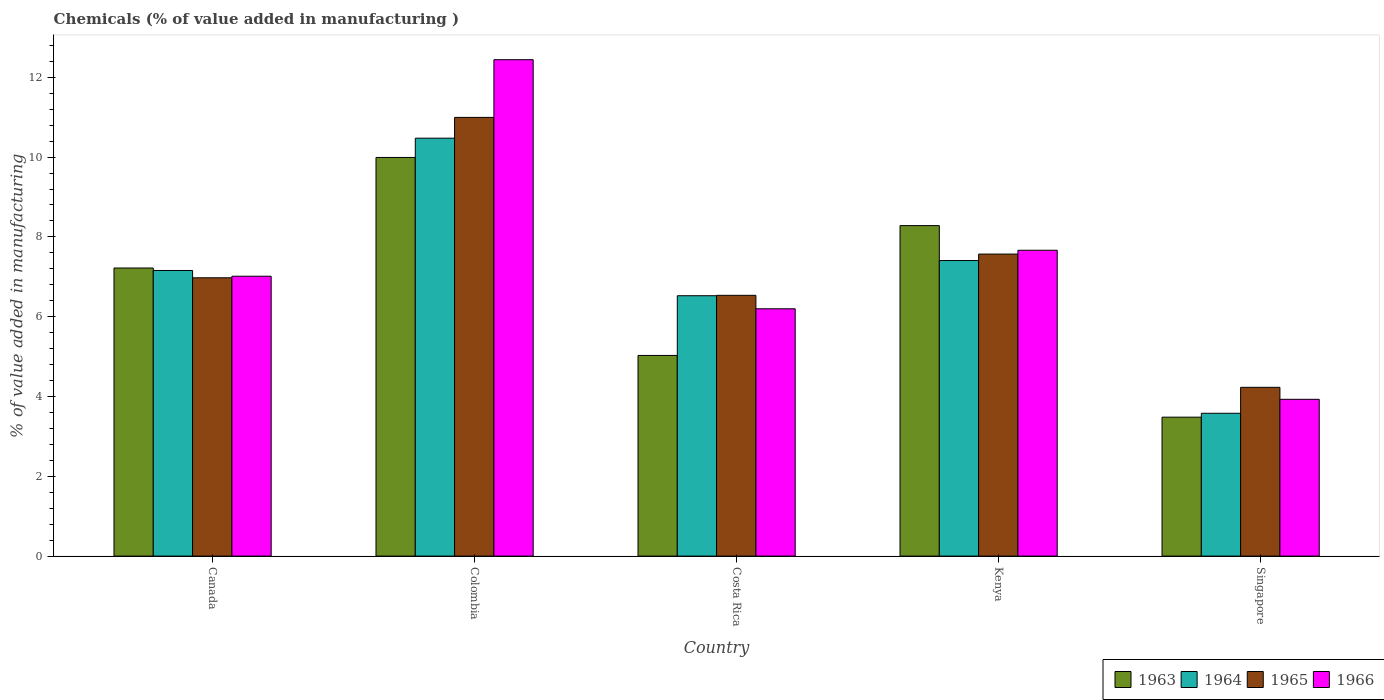How many groups of bars are there?
Your answer should be compact. 5. Are the number of bars on each tick of the X-axis equal?
Ensure brevity in your answer.  Yes. How many bars are there on the 2nd tick from the left?
Your answer should be compact. 4. What is the label of the 4th group of bars from the left?
Keep it short and to the point. Kenya. In how many cases, is the number of bars for a given country not equal to the number of legend labels?
Your answer should be very brief. 0. What is the value added in manufacturing chemicals in 1966 in Singapore?
Your answer should be compact. 3.93. Across all countries, what is the maximum value added in manufacturing chemicals in 1966?
Keep it short and to the point. 12.44. Across all countries, what is the minimum value added in manufacturing chemicals in 1966?
Provide a succinct answer. 3.93. In which country was the value added in manufacturing chemicals in 1965 minimum?
Offer a very short reply. Singapore. What is the total value added in manufacturing chemicals in 1965 in the graph?
Offer a very short reply. 36.31. What is the difference between the value added in manufacturing chemicals in 1966 in Colombia and that in Singapore?
Make the answer very short. 8.51. What is the difference between the value added in manufacturing chemicals in 1965 in Colombia and the value added in manufacturing chemicals in 1966 in Costa Rica?
Provide a short and direct response. 4.8. What is the average value added in manufacturing chemicals in 1963 per country?
Keep it short and to the point. 6.8. What is the difference between the value added in manufacturing chemicals of/in 1963 and value added in manufacturing chemicals of/in 1966 in Kenya?
Offer a terse response. 0.62. In how many countries, is the value added in manufacturing chemicals in 1963 greater than 4.4 %?
Keep it short and to the point. 4. What is the ratio of the value added in manufacturing chemicals in 1965 in Kenya to that in Singapore?
Make the answer very short. 1.79. Is the value added in manufacturing chemicals in 1963 in Colombia less than that in Kenya?
Your response must be concise. No. Is the difference between the value added in manufacturing chemicals in 1963 in Colombia and Costa Rica greater than the difference between the value added in manufacturing chemicals in 1966 in Colombia and Costa Rica?
Ensure brevity in your answer.  No. What is the difference between the highest and the second highest value added in manufacturing chemicals in 1965?
Offer a very short reply. 4.02. What is the difference between the highest and the lowest value added in manufacturing chemicals in 1963?
Your response must be concise. 6.51. In how many countries, is the value added in manufacturing chemicals in 1965 greater than the average value added in manufacturing chemicals in 1965 taken over all countries?
Provide a succinct answer. 2. Is the sum of the value added in manufacturing chemicals in 1963 in Costa Rica and Singapore greater than the maximum value added in manufacturing chemicals in 1965 across all countries?
Ensure brevity in your answer.  No. What does the 3rd bar from the left in Colombia represents?
Make the answer very short. 1965. What does the 1st bar from the right in Colombia represents?
Your answer should be very brief. 1966. Are all the bars in the graph horizontal?
Ensure brevity in your answer.  No. How many countries are there in the graph?
Provide a succinct answer. 5. What is the difference between two consecutive major ticks on the Y-axis?
Provide a short and direct response. 2. Are the values on the major ticks of Y-axis written in scientific E-notation?
Give a very brief answer. No. Does the graph contain any zero values?
Offer a very short reply. No. Does the graph contain grids?
Keep it short and to the point. No. Where does the legend appear in the graph?
Give a very brief answer. Bottom right. How many legend labels are there?
Keep it short and to the point. 4. What is the title of the graph?
Your response must be concise. Chemicals (% of value added in manufacturing ). What is the label or title of the X-axis?
Keep it short and to the point. Country. What is the label or title of the Y-axis?
Your answer should be compact. % of value added in manufacturing. What is the % of value added in manufacturing in 1963 in Canada?
Your response must be concise. 7.22. What is the % of value added in manufacturing of 1964 in Canada?
Keep it short and to the point. 7.16. What is the % of value added in manufacturing in 1965 in Canada?
Your answer should be very brief. 6.98. What is the % of value added in manufacturing in 1966 in Canada?
Offer a very short reply. 7.01. What is the % of value added in manufacturing in 1963 in Colombia?
Ensure brevity in your answer.  9.99. What is the % of value added in manufacturing in 1964 in Colombia?
Ensure brevity in your answer.  10.47. What is the % of value added in manufacturing of 1965 in Colombia?
Your answer should be compact. 10.99. What is the % of value added in manufacturing in 1966 in Colombia?
Your answer should be compact. 12.44. What is the % of value added in manufacturing in 1963 in Costa Rica?
Offer a terse response. 5.03. What is the % of value added in manufacturing of 1964 in Costa Rica?
Give a very brief answer. 6.53. What is the % of value added in manufacturing of 1965 in Costa Rica?
Provide a short and direct response. 6.54. What is the % of value added in manufacturing in 1966 in Costa Rica?
Offer a very short reply. 6.2. What is the % of value added in manufacturing of 1963 in Kenya?
Ensure brevity in your answer.  8.28. What is the % of value added in manufacturing of 1964 in Kenya?
Your answer should be very brief. 7.41. What is the % of value added in manufacturing of 1965 in Kenya?
Your response must be concise. 7.57. What is the % of value added in manufacturing of 1966 in Kenya?
Your answer should be compact. 7.67. What is the % of value added in manufacturing in 1963 in Singapore?
Your answer should be compact. 3.48. What is the % of value added in manufacturing of 1964 in Singapore?
Ensure brevity in your answer.  3.58. What is the % of value added in manufacturing of 1965 in Singapore?
Make the answer very short. 4.23. What is the % of value added in manufacturing of 1966 in Singapore?
Keep it short and to the point. 3.93. Across all countries, what is the maximum % of value added in manufacturing of 1963?
Your answer should be compact. 9.99. Across all countries, what is the maximum % of value added in manufacturing of 1964?
Keep it short and to the point. 10.47. Across all countries, what is the maximum % of value added in manufacturing of 1965?
Offer a very short reply. 10.99. Across all countries, what is the maximum % of value added in manufacturing in 1966?
Offer a terse response. 12.44. Across all countries, what is the minimum % of value added in manufacturing of 1963?
Your response must be concise. 3.48. Across all countries, what is the minimum % of value added in manufacturing of 1964?
Keep it short and to the point. 3.58. Across all countries, what is the minimum % of value added in manufacturing of 1965?
Keep it short and to the point. 4.23. Across all countries, what is the minimum % of value added in manufacturing of 1966?
Your response must be concise. 3.93. What is the total % of value added in manufacturing of 1963 in the graph?
Your response must be concise. 34.01. What is the total % of value added in manufacturing of 1964 in the graph?
Ensure brevity in your answer.  35.15. What is the total % of value added in manufacturing of 1965 in the graph?
Provide a short and direct response. 36.31. What is the total % of value added in manufacturing of 1966 in the graph?
Offer a very short reply. 37.25. What is the difference between the % of value added in manufacturing of 1963 in Canada and that in Colombia?
Make the answer very short. -2.77. What is the difference between the % of value added in manufacturing in 1964 in Canada and that in Colombia?
Offer a terse response. -3.32. What is the difference between the % of value added in manufacturing in 1965 in Canada and that in Colombia?
Provide a succinct answer. -4.02. What is the difference between the % of value added in manufacturing of 1966 in Canada and that in Colombia?
Give a very brief answer. -5.43. What is the difference between the % of value added in manufacturing of 1963 in Canada and that in Costa Rica?
Your answer should be very brief. 2.19. What is the difference between the % of value added in manufacturing of 1964 in Canada and that in Costa Rica?
Keep it short and to the point. 0.63. What is the difference between the % of value added in manufacturing in 1965 in Canada and that in Costa Rica?
Provide a short and direct response. 0.44. What is the difference between the % of value added in manufacturing of 1966 in Canada and that in Costa Rica?
Keep it short and to the point. 0.82. What is the difference between the % of value added in manufacturing in 1963 in Canada and that in Kenya?
Your answer should be compact. -1.06. What is the difference between the % of value added in manufacturing of 1964 in Canada and that in Kenya?
Keep it short and to the point. -0.25. What is the difference between the % of value added in manufacturing of 1965 in Canada and that in Kenya?
Provide a short and direct response. -0.59. What is the difference between the % of value added in manufacturing in 1966 in Canada and that in Kenya?
Your response must be concise. -0.65. What is the difference between the % of value added in manufacturing of 1963 in Canada and that in Singapore?
Your answer should be very brief. 3.74. What is the difference between the % of value added in manufacturing in 1964 in Canada and that in Singapore?
Make the answer very short. 3.58. What is the difference between the % of value added in manufacturing of 1965 in Canada and that in Singapore?
Make the answer very short. 2.75. What is the difference between the % of value added in manufacturing in 1966 in Canada and that in Singapore?
Provide a short and direct response. 3.08. What is the difference between the % of value added in manufacturing in 1963 in Colombia and that in Costa Rica?
Make the answer very short. 4.96. What is the difference between the % of value added in manufacturing in 1964 in Colombia and that in Costa Rica?
Your answer should be compact. 3.95. What is the difference between the % of value added in manufacturing in 1965 in Colombia and that in Costa Rica?
Keep it short and to the point. 4.46. What is the difference between the % of value added in manufacturing of 1966 in Colombia and that in Costa Rica?
Your response must be concise. 6.24. What is the difference between the % of value added in manufacturing in 1963 in Colombia and that in Kenya?
Keep it short and to the point. 1.71. What is the difference between the % of value added in manufacturing in 1964 in Colombia and that in Kenya?
Make the answer very short. 3.07. What is the difference between the % of value added in manufacturing in 1965 in Colombia and that in Kenya?
Your answer should be very brief. 3.43. What is the difference between the % of value added in manufacturing of 1966 in Colombia and that in Kenya?
Ensure brevity in your answer.  4.78. What is the difference between the % of value added in manufacturing in 1963 in Colombia and that in Singapore?
Provide a succinct answer. 6.51. What is the difference between the % of value added in manufacturing of 1964 in Colombia and that in Singapore?
Your answer should be compact. 6.89. What is the difference between the % of value added in manufacturing of 1965 in Colombia and that in Singapore?
Make the answer very short. 6.76. What is the difference between the % of value added in manufacturing of 1966 in Colombia and that in Singapore?
Make the answer very short. 8.51. What is the difference between the % of value added in manufacturing of 1963 in Costa Rica and that in Kenya?
Provide a succinct answer. -3.25. What is the difference between the % of value added in manufacturing in 1964 in Costa Rica and that in Kenya?
Make the answer very short. -0.88. What is the difference between the % of value added in manufacturing in 1965 in Costa Rica and that in Kenya?
Provide a short and direct response. -1.03. What is the difference between the % of value added in manufacturing of 1966 in Costa Rica and that in Kenya?
Offer a very short reply. -1.47. What is the difference between the % of value added in manufacturing of 1963 in Costa Rica and that in Singapore?
Your answer should be compact. 1.55. What is the difference between the % of value added in manufacturing in 1964 in Costa Rica and that in Singapore?
Your answer should be compact. 2.95. What is the difference between the % of value added in manufacturing of 1965 in Costa Rica and that in Singapore?
Offer a terse response. 2.31. What is the difference between the % of value added in manufacturing in 1966 in Costa Rica and that in Singapore?
Your response must be concise. 2.27. What is the difference between the % of value added in manufacturing in 1963 in Kenya and that in Singapore?
Provide a short and direct response. 4.8. What is the difference between the % of value added in manufacturing of 1964 in Kenya and that in Singapore?
Make the answer very short. 3.83. What is the difference between the % of value added in manufacturing of 1965 in Kenya and that in Singapore?
Your answer should be very brief. 3.34. What is the difference between the % of value added in manufacturing in 1966 in Kenya and that in Singapore?
Provide a succinct answer. 3.74. What is the difference between the % of value added in manufacturing in 1963 in Canada and the % of value added in manufacturing in 1964 in Colombia?
Give a very brief answer. -3.25. What is the difference between the % of value added in manufacturing of 1963 in Canada and the % of value added in manufacturing of 1965 in Colombia?
Your response must be concise. -3.77. What is the difference between the % of value added in manufacturing in 1963 in Canada and the % of value added in manufacturing in 1966 in Colombia?
Provide a short and direct response. -5.22. What is the difference between the % of value added in manufacturing of 1964 in Canada and the % of value added in manufacturing of 1965 in Colombia?
Offer a very short reply. -3.84. What is the difference between the % of value added in manufacturing of 1964 in Canada and the % of value added in manufacturing of 1966 in Colombia?
Give a very brief answer. -5.28. What is the difference between the % of value added in manufacturing in 1965 in Canada and the % of value added in manufacturing in 1966 in Colombia?
Give a very brief answer. -5.47. What is the difference between the % of value added in manufacturing in 1963 in Canada and the % of value added in manufacturing in 1964 in Costa Rica?
Make the answer very short. 0.69. What is the difference between the % of value added in manufacturing of 1963 in Canada and the % of value added in manufacturing of 1965 in Costa Rica?
Offer a terse response. 0.68. What is the difference between the % of value added in manufacturing in 1963 in Canada and the % of value added in manufacturing in 1966 in Costa Rica?
Provide a succinct answer. 1.02. What is the difference between the % of value added in manufacturing in 1964 in Canada and the % of value added in manufacturing in 1965 in Costa Rica?
Make the answer very short. 0.62. What is the difference between the % of value added in manufacturing in 1964 in Canada and the % of value added in manufacturing in 1966 in Costa Rica?
Provide a short and direct response. 0.96. What is the difference between the % of value added in manufacturing of 1965 in Canada and the % of value added in manufacturing of 1966 in Costa Rica?
Provide a succinct answer. 0.78. What is the difference between the % of value added in manufacturing of 1963 in Canada and the % of value added in manufacturing of 1964 in Kenya?
Your response must be concise. -0.19. What is the difference between the % of value added in manufacturing of 1963 in Canada and the % of value added in manufacturing of 1965 in Kenya?
Give a very brief answer. -0.35. What is the difference between the % of value added in manufacturing of 1963 in Canada and the % of value added in manufacturing of 1966 in Kenya?
Ensure brevity in your answer.  -0.44. What is the difference between the % of value added in manufacturing in 1964 in Canada and the % of value added in manufacturing in 1965 in Kenya?
Your response must be concise. -0.41. What is the difference between the % of value added in manufacturing in 1964 in Canada and the % of value added in manufacturing in 1966 in Kenya?
Offer a terse response. -0.51. What is the difference between the % of value added in manufacturing of 1965 in Canada and the % of value added in manufacturing of 1966 in Kenya?
Offer a terse response. -0.69. What is the difference between the % of value added in manufacturing in 1963 in Canada and the % of value added in manufacturing in 1964 in Singapore?
Provide a short and direct response. 3.64. What is the difference between the % of value added in manufacturing of 1963 in Canada and the % of value added in manufacturing of 1965 in Singapore?
Ensure brevity in your answer.  2.99. What is the difference between the % of value added in manufacturing of 1963 in Canada and the % of value added in manufacturing of 1966 in Singapore?
Your answer should be compact. 3.29. What is the difference between the % of value added in manufacturing in 1964 in Canada and the % of value added in manufacturing in 1965 in Singapore?
Keep it short and to the point. 2.93. What is the difference between the % of value added in manufacturing of 1964 in Canada and the % of value added in manufacturing of 1966 in Singapore?
Give a very brief answer. 3.23. What is the difference between the % of value added in manufacturing in 1965 in Canada and the % of value added in manufacturing in 1966 in Singapore?
Make the answer very short. 3.05. What is the difference between the % of value added in manufacturing of 1963 in Colombia and the % of value added in manufacturing of 1964 in Costa Rica?
Your answer should be compact. 3.47. What is the difference between the % of value added in manufacturing in 1963 in Colombia and the % of value added in manufacturing in 1965 in Costa Rica?
Provide a short and direct response. 3.46. What is the difference between the % of value added in manufacturing in 1963 in Colombia and the % of value added in manufacturing in 1966 in Costa Rica?
Provide a succinct answer. 3.79. What is the difference between the % of value added in manufacturing in 1964 in Colombia and the % of value added in manufacturing in 1965 in Costa Rica?
Your response must be concise. 3.94. What is the difference between the % of value added in manufacturing of 1964 in Colombia and the % of value added in manufacturing of 1966 in Costa Rica?
Offer a terse response. 4.28. What is the difference between the % of value added in manufacturing in 1965 in Colombia and the % of value added in manufacturing in 1966 in Costa Rica?
Offer a very short reply. 4.8. What is the difference between the % of value added in manufacturing of 1963 in Colombia and the % of value added in manufacturing of 1964 in Kenya?
Provide a short and direct response. 2.58. What is the difference between the % of value added in manufacturing in 1963 in Colombia and the % of value added in manufacturing in 1965 in Kenya?
Keep it short and to the point. 2.42. What is the difference between the % of value added in manufacturing of 1963 in Colombia and the % of value added in manufacturing of 1966 in Kenya?
Give a very brief answer. 2.33. What is the difference between the % of value added in manufacturing in 1964 in Colombia and the % of value added in manufacturing in 1965 in Kenya?
Provide a succinct answer. 2.9. What is the difference between the % of value added in manufacturing of 1964 in Colombia and the % of value added in manufacturing of 1966 in Kenya?
Keep it short and to the point. 2.81. What is the difference between the % of value added in manufacturing in 1965 in Colombia and the % of value added in manufacturing in 1966 in Kenya?
Provide a succinct answer. 3.33. What is the difference between the % of value added in manufacturing in 1963 in Colombia and the % of value added in manufacturing in 1964 in Singapore?
Provide a short and direct response. 6.41. What is the difference between the % of value added in manufacturing in 1963 in Colombia and the % of value added in manufacturing in 1965 in Singapore?
Offer a very short reply. 5.76. What is the difference between the % of value added in manufacturing in 1963 in Colombia and the % of value added in manufacturing in 1966 in Singapore?
Give a very brief answer. 6.06. What is the difference between the % of value added in manufacturing in 1964 in Colombia and the % of value added in manufacturing in 1965 in Singapore?
Your answer should be very brief. 6.24. What is the difference between the % of value added in manufacturing in 1964 in Colombia and the % of value added in manufacturing in 1966 in Singapore?
Your answer should be very brief. 6.54. What is the difference between the % of value added in manufacturing in 1965 in Colombia and the % of value added in manufacturing in 1966 in Singapore?
Your response must be concise. 7.07. What is the difference between the % of value added in manufacturing in 1963 in Costa Rica and the % of value added in manufacturing in 1964 in Kenya?
Your answer should be very brief. -2.38. What is the difference between the % of value added in manufacturing of 1963 in Costa Rica and the % of value added in manufacturing of 1965 in Kenya?
Your answer should be very brief. -2.54. What is the difference between the % of value added in manufacturing in 1963 in Costa Rica and the % of value added in manufacturing in 1966 in Kenya?
Your answer should be very brief. -2.64. What is the difference between the % of value added in manufacturing in 1964 in Costa Rica and the % of value added in manufacturing in 1965 in Kenya?
Provide a succinct answer. -1.04. What is the difference between the % of value added in manufacturing in 1964 in Costa Rica and the % of value added in manufacturing in 1966 in Kenya?
Provide a short and direct response. -1.14. What is the difference between the % of value added in manufacturing of 1965 in Costa Rica and the % of value added in manufacturing of 1966 in Kenya?
Keep it short and to the point. -1.13. What is the difference between the % of value added in manufacturing of 1963 in Costa Rica and the % of value added in manufacturing of 1964 in Singapore?
Your answer should be compact. 1.45. What is the difference between the % of value added in manufacturing of 1963 in Costa Rica and the % of value added in manufacturing of 1965 in Singapore?
Make the answer very short. 0.8. What is the difference between the % of value added in manufacturing of 1963 in Costa Rica and the % of value added in manufacturing of 1966 in Singapore?
Your answer should be very brief. 1.1. What is the difference between the % of value added in manufacturing of 1964 in Costa Rica and the % of value added in manufacturing of 1965 in Singapore?
Ensure brevity in your answer.  2.3. What is the difference between the % of value added in manufacturing of 1964 in Costa Rica and the % of value added in manufacturing of 1966 in Singapore?
Keep it short and to the point. 2.6. What is the difference between the % of value added in manufacturing of 1965 in Costa Rica and the % of value added in manufacturing of 1966 in Singapore?
Make the answer very short. 2.61. What is the difference between the % of value added in manufacturing in 1963 in Kenya and the % of value added in manufacturing in 1964 in Singapore?
Provide a succinct answer. 4.7. What is the difference between the % of value added in manufacturing in 1963 in Kenya and the % of value added in manufacturing in 1965 in Singapore?
Offer a terse response. 4.05. What is the difference between the % of value added in manufacturing in 1963 in Kenya and the % of value added in manufacturing in 1966 in Singapore?
Provide a succinct answer. 4.35. What is the difference between the % of value added in manufacturing of 1964 in Kenya and the % of value added in manufacturing of 1965 in Singapore?
Keep it short and to the point. 3.18. What is the difference between the % of value added in manufacturing in 1964 in Kenya and the % of value added in manufacturing in 1966 in Singapore?
Offer a very short reply. 3.48. What is the difference between the % of value added in manufacturing of 1965 in Kenya and the % of value added in manufacturing of 1966 in Singapore?
Provide a short and direct response. 3.64. What is the average % of value added in manufacturing in 1963 per country?
Your answer should be very brief. 6.8. What is the average % of value added in manufacturing in 1964 per country?
Provide a succinct answer. 7.03. What is the average % of value added in manufacturing of 1965 per country?
Keep it short and to the point. 7.26. What is the average % of value added in manufacturing of 1966 per country?
Offer a terse response. 7.45. What is the difference between the % of value added in manufacturing in 1963 and % of value added in manufacturing in 1964 in Canada?
Offer a terse response. 0.06. What is the difference between the % of value added in manufacturing in 1963 and % of value added in manufacturing in 1965 in Canada?
Give a very brief answer. 0.25. What is the difference between the % of value added in manufacturing of 1963 and % of value added in manufacturing of 1966 in Canada?
Give a very brief answer. 0.21. What is the difference between the % of value added in manufacturing of 1964 and % of value added in manufacturing of 1965 in Canada?
Your answer should be very brief. 0.18. What is the difference between the % of value added in manufacturing in 1964 and % of value added in manufacturing in 1966 in Canada?
Give a very brief answer. 0.14. What is the difference between the % of value added in manufacturing in 1965 and % of value added in manufacturing in 1966 in Canada?
Your response must be concise. -0.04. What is the difference between the % of value added in manufacturing in 1963 and % of value added in manufacturing in 1964 in Colombia?
Provide a short and direct response. -0.48. What is the difference between the % of value added in manufacturing of 1963 and % of value added in manufacturing of 1965 in Colombia?
Offer a very short reply. -1. What is the difference between the % of value added in manufacturing of 1963 and % of value added in manufacturing of 1966 in Colombia?
Offer a terse response. -2.45. What is the difference between the % of value added in manufacturing of 1964 and % of value added in manufacturing of 1965 in Colombia?
Offer a terse response. -0.52. What is the difference between the % of value added in manufacturing in 1964 and % of value added in manufacturing in 1966 in Colombia?
Offer a terse response. -1.97. What is the difference between the % of value added in manufacturing in 1965 and % of value added in manufacturing in 1966 in Colombia?
Offer a very short reply. -1.45. What is the difference between the % of value added in manufacturing in 1963 and % of value added in manufacturing in 1964 in Costa Rica?
Ensure brevity in your answer.  -1.5. What is the difference between the % of value added in manufacturing of 1963 and % of value added in manufacturing of 1965 in Costa Rica?
Provide a succinct answer. -1.51. What is the difference between the % of value added in manufacturing of 1963 and % of value added in manufacturing of 1966 in Costa Rica?
Offer a terse response. -1.17. What is the difference between the % of value added in manufacturing of 1964 and % of value added in manufacturing of 1965 in Costa Rica?
Your answer should be compact. -0.01. What is the difference between the % of value added in manufacturing of 1964 and % of value added in manufacturing of 1966 in Costa Rica?
Your response must be concise. 0.33. What is the difference between the % of value added in manufacturing of 1965 and % of value added in manufacturing of 1966 in Costa Rica?
Give a very brief answer. 0.34. What is the difference between the % of value added in manufacturing in 1963 and % of value added in manufacturing in 1964 in Kenya?
Offer a very short reply. 0.87. What is the difference between the % of value added in manufacturing in 1963 and % of value added in manufacturing in 1965 in Kenya?
Provide a succinct answer. 0.71. What is the difference between the % of value added in manufacturing of 1963 and % of value added in manufacturing of 1966 in Kenya?
Your response must be concise. 0.62. What is the difference between the % of value added in manufacturing of 1964 and % of value added in manufacturing of 1965 in Kenya?
Provide a short and direct response. -0.16. What is the difference between the % of value added in manufacturing of 1964 and % of value added in manufacturing of 1966 in Kenya?
Ensure brevity in your answer.  -0.26. What is the difference between the % of value added in manufacturing in 1965 and % of value added in manufacturing in 1966 in Kenya?
Make the answer very short. -0.1. What is the difference between the % of value added in manufacturing of 1963 and % of value added in manufacturing of 1964 in Singapore?
Your response must be concise. -0.1. What is the difference between the % of value added in manufacturing of 1963 and % of value added in manufacturing of 1965 in Singapore?
Your response must be concise. -0.75. What is the difference between the % of value added in manufacturing of 1963 and % of value added in manufacturing of 1966 in Singapore?
Provide a short and direct response. -0.45. What is the difference between the % of value added in manufacturing in 1964 and % of value added in manufacturing in 1965 in Singapore?
Provide a short and direct response. -0.65. What is the difference between the % of value added in manufacturing of 1964 and % of value added in manufacturing of 1966 in Singapore?
Provide a succinct answer. -0.35. What is the difference between the % of value added in manufacturing in 1965 and % of value added in manufacturing in 1966 in Singapore?
Your answer should be very brief. 0.3. What is the ratio of the % of value added in manufacturing in 1963 in Canada to that in Colombia?
Give a very brief answer. 0.72. What is the ratio of the % of value added in manufacturing in 1964 in Canada to that in Colombia?
Ensure brevity in your answer.  0.68. What is the ratio of the % of value added in manufacturing of 1965 in Canada to that in Colombia?
Make the answer very short. 0.63. What is the ratio of the % of value added in manufacturing in 1966 in Canada to that in Colombia?
Your answer should be very brief. 0.56. What is the ratio of the % of value added in manufacturing in 1963 in Canada to that in Costa Rica?
Your answer should be compact. 1.44. What is the ratio of the % of value added in manufacturing of 1964 in Canada to that in Costa Rica?
Make the answer very short. 1.1. What is the ratio of the % of value added in manufacturing of 1965 in Canada to that in Costa Rica?
Ensure brevity in your answer.  1.07. What is the ratio of the % of value added in manufacturing in 1966 in Canada to that in Costa Rica?
Provide a succinct answer. 1.13. What is the ratio of the % of value added in manufacturing in 1963 in Canada to that in Kenya?
Your answer should be compact. 0.87. What is the ratio of the % of value added in manufacturing in 1964 in Canada to that in Kenya?
Your response must be concise. 0.97. What is the ratio of the % of value added in manufacturing in 1965 in Canada to that in Kenya?
Your answer should be very brief. 0.92. What is the ratio of the % of value added in manufacturing of 1966 in Canada to that in Kenya?
Offer a very short reply. 0.92. What is the ratio of the % of value added in manufacturing in 1963 in Canada to that in Singapore?
Your answer should be very brief. 2.07. What is the ratio of the % of value added in manufacturing of 1964 in Canada to that in Singapore?
Make the answer very short. 2. What is the ratio of the % of value added in manufacturing in 1965 in Canada to that in Singapore?
Your response must be concise. 1.65. What is the ratio of the % of value added in manufacturing of 1966 in Canada to that in Singapore?
Keep it short and to the point. 1.78. What is the ratio of the % of value added in manufacturing of 1963 in Colombia to that in Costa Rica?
Keep it short and to the point. 1.99. What is the ratio of the % of value added in manufacturing in 1964 in Colombia to that in Costa Rica?
Keep it short and to the point. 1.61. What is the ratio of the % of value added in manufacturing in 1965 in Colombia to that in Costa Rica?
Give a very brief answer. 1.68. What is the ratio of the % of value added in manufacturing in 1966 in Colombia to that in Costa Rica?
Provide a succinct answer. 2.01. What is the ratio of the % of value added in manufacturing in 1963 in Colombia to that in Kenya?
Your answer should be very brief. 1.21. What is the ratio of the % of value added in manufacturing of 1964 in Colombia to that in Kenya?
Keep it short and to the point. 1.41. What is the ratio of the % of value added in manufacturing in 1965 in Colombia to that in Kenya?
Your answer should be compact. 1.45. What is the ratio of the % of value added in manufacturing in 1966 in Colombia to that in Kenya?
Provide a short and direct response. 1.62. What is the ratio of the % of value added in manufacturing of 1963 in Colombia to that in Singapore?
Offer a terse response. 2.87. What is the ratio of the % of value added in manufacturing in 1964 in Colombia to that in Singapore?
Provide a short and direct response. 2.93. What is the ratio of the % of value added in manufacturing of 1965 in Colombia to that in Singapore?
Offer a very short reply. 2.6. What is the ratio of the % of value added in manufacturing of 1966 in Colombia to that in Singapore?
Provide a succinct answer. 3.17. What is the ratio of the % of value added in manufacturing in 1963 in Costa Rica to that in Kenya?
Provide a short and direct response. 0.61. What is the ratio of the % of value added in manufacturing of 1964 in Costa Rica to that in Kenya?
Offer a terse response. 0.88. What is the ratio of the % of value added in manufacturing in 1965 in Costa Rica to that in Kenya?
Ensure brevity in your answer.  0.86. What is the ratio of the % of value added in manufacturing in 1966 in Costa Rica to that in Kenya?
Your answer should be compact. 0.81. What is the ratio of the % of value added in manufacturing in 1963 in Costa Rica to that in Singapore?
Ensure brevity in your answer.  1.44. What is the ratio of the % of value added in manufacturing in 1964 in Costa Rica to that in Singapore?
Provide a succinct answer. 1.82. What is the ratio of the % of value added in manufacturing in 1965 in Costa Rica to that in Singapore?
Offer a very short reply. 1.55. What is the ratio of the % of value added in manufacturing in 1966 in Costa Rica to that in Singapore?
Your response must be concise. 1.58. What is the ratio of the % of value added in manufacturing in 1963 in Kenya to that in Singapore?
Give a very brief answer. 2.38. What is the ratio of the % of value added in manufacturing of 1964 in Kenya to that in Singapore?
Your answer should be very brief. 2.07. What is the ratio of the % of value added in manufacturing in 1965 in Kenya to that in Singapore?
Offer a terse response. 1.79. What is the ratio of the % of value added in manufacturing of 1966 in Kenya to that in Singapore?
Provide a short and direct response. 1.95. What is the difference between the highest and the second highest % of value added in manufacturing of 1963?
Offer a very short reply. 1.71. What is the difference between the highest and the second highest % of value added in manufacturing in 1964?
Give a very brief answer. 3.07. What is the difference between the highest and the second highest % of value added in manufacturing in 1965?
Give a very brief answer. 3.43. What is the difference between the highest and the second highest % of value added in manufacturing of 1966?
Your answer should be compact. 4.78. What is the difference between the highest and the lowest % of value added in manufacturing in 1963?
Your response must be concise. 6.51. What is the difference between the highest and the lowest % of value added in manufacturing of 1964?
Offer a terse response. 6.89. What is the difference between the highest and the lowest % of value added in manufacturing in 1965?
Ensure brevity in your answer.  6.76. What is the difference between the highest and the lowest % of value added in manufacturing of 1966?
Ensure brevity in your answer.  8.51. 